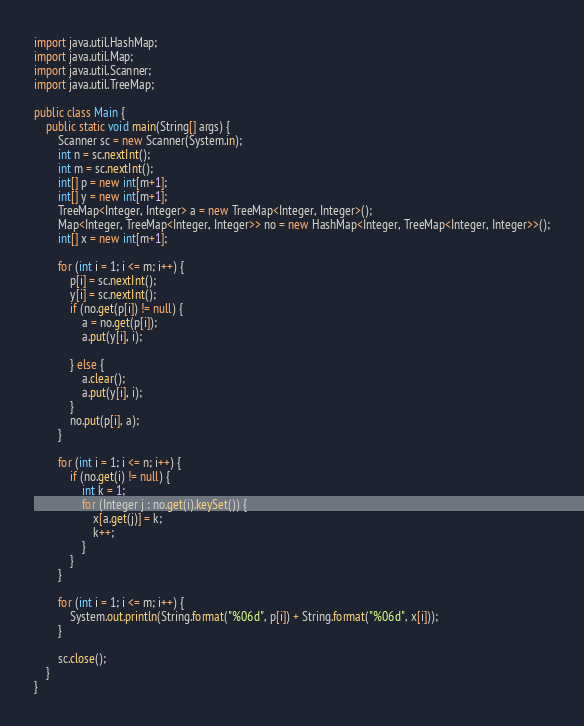<code> <loc_0><loc_0><loc_500><loc_500><_Java_>import java.util.HashMap;
import java.util.Map;
import java.util.Scanner;
import java.util.TreeMap;

public class Main {
	public static void main(String[] args) {
		Scanner sc = new Scanner(System.in);
		int n = sc.nextInt();
		int m = sc.nextInt();
		int[] p = new int[m+1];
		int[] y = new int[m+1];
		TreeMap<Integer, Integer> a = new TreeMap<Integer, Integer>();
		Map<Integer, TreeMap<Integer, Integer>> no = new HashMap<Integer, TreeMap<Integer, Integer>>();
		int[] x = new int[m+1];

		for (int i = 1; i <= m; i++) {
			p[i] = sc.nextInt();
			y[i] = sc.nextInt();
			if (no.get(p[i]) != null) {
				a = no.get(p[i]);
				a.put(y[i], i);

			} else {
				a.clear();
				a.put(y[i], i);
			}
			no.put(p[i], a);
		}

		for (int i = 1; i <= n; i++) {
			if (no.get(i) != null) {
				int k = 1;
				for (Integer j : no.get(i).keySet()) {
					x[a.get(j)] = k;
					k++;
				}
			}
		}

		for (int i = 1; i <= m; i++) {
			System.out.println(String.format("%06d", p[i]) + String.format("%06d", x[i]));
		}

		sc.close();
	}
}
</code> 